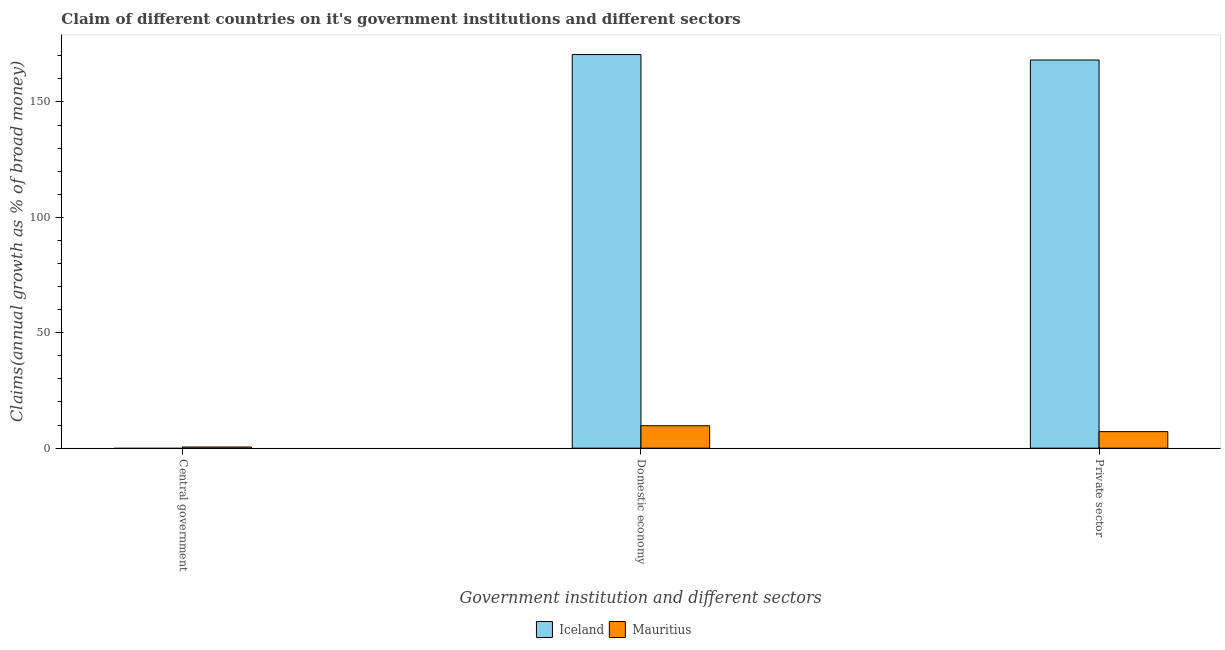How many different coloured bars are there?
Offer a terse response. 2. Are the number of bars per tick equal to the number of legend labels?
Ensure brevity in your answer.  No. Are the number of bars on each tick of the X-axis equal?
Your response must be concise. No. How many bars are there on the 3rd tick from the left?
Offer a terse response. 2. What is the label of the 2nd group of bars from the left?
Your response must be concise. Domestic economy. What is the percentage of claim on the domestic economy in Mauritius?
Provide a succinct answer. 9.7. Across all countries, what is the maximum percentage of claim on the central government?
Offer a very short reply. 0.49. Across all countries, what is the minimum percentage of claim on the central government?
Offer a terse response. 0. In which country was the percentage of claim on the private sector maximum?
Provide a succinct answer. Iceland. What is the total percentage of claim on the private sector in the graph?
Your answer should be compact. 175.32. What is the difference between the percentage of claim on the private sector in Iceland and that in Mauritius?
Offer a very short reply. 161. What is the difference between the percentage of claim on the private sector in Iceland and the percentage of claim on the central government in Mauritius?
Keep it short and to the point. 167.67. What is the average percentage of claim on the private sector per country?
Your answer should be very brief. 87.66. What is the difference between the percentage of claim on the private sector and percentage of claim on the domestic economy in Mauritius?
Offer a terse response. -2.55. What is the ratio of the percentage of claim on the domestic economy in Mauritius to that in Iceland?
Offer a very short reply. 0.06. What is the difference between the highest and the second highest percentage of claim on the domestic economy?
Offer a terse response. 160.81. What is the difference between the highest and the lowest percentage of claim on the private sector?
Make the answer very short. 161. In how many countries, is the percentage of claim on the central government greater than the average percentage of claim on the central government taken over all countries?
Provide a short and direct response. 1. Is the sum of the percentage of claim on the private sector in Mauritius and Iceland greater than the maximum percentage of claim on the domestic economy across all countries?
Ensure brevity in your answer.  Yes. Is it the case that in every country, the sum of the percentage of claim on the central government and percentage of claim on the domestic economy is greater than the percentage of claim on the private sector?
Ensure brevity in your answer.  Yes. Does the graph contain any zero values?
Provide a short and direct response. Yes. Does the graph contain grids?
Your answer should be very brief. No. Where does the legend appear in the graph?
Provide a succinct answer. Bottom center. How many legend labels are there?
Your answer should be very brief. 2. How are the legend labels stacked?
Offer a terse response. Horizontal. What is the title of the graph?
Your response must be concise. Claim of different countries on it's government institutions and different sectors. What is the label or title of the X-axis?
Keep it short and to the point. Government institution and different sectors. What is the label or title of the Y-axis?
Ensure brevity in your answer.  Claims(annual growth as % of broad money). What is the Claims(annual growth as % of broad money) of Mauritius in Central government?
Your answer should be compact. 0.49. What is the Claims(annual growth as % of broad money) in Iceland in Domestic economy?
Offer a terse response. 170.52. What is the Claims(annual growth as % of broad money) of Mauritius in Domestic economy?
Your answer should be compact. 9.7. What is the Claims(annual growth as % of broad money) of Iceland in Private sector?
Make the answer very short. 168.16. What is the Claims(annual growth as % of broad money) of Mauritius in Private sector?
Give a very brief answer. 7.16. Across all Government institution and different sectors, what is the maximum Claims(annual growth as % of broad money) in Iceland?
Provide a short and direct response. 170.52. Across all Government institution and different sectors, what is the maximum Claims(annual growth as % of broad money) of Mauritius?
Your answer should be very brief. 9.7. Across all Government institution and different sectors, what is the minimum Claims(annual growth as % of broad money) in Iceland?
Provide a short and direct response. 0. Across all Government institution and different sectors, what is the minimum Claims(annual growth as % of broad money) in Mauritius?
Provide a succinct answer. 0.49. What is the total Claims(annual growth as % of broad money) of Iceland in the graph?
Provide a short and direct response. 338.68. What is the total Claims(annual growth as % of broad money) in Mauritius in the graph?
Your response must be concise. 17.35. What is the difference between the Claims(annual growth as % of broad money) of Mauritius in Central government and that in Domestic economy?
Provide a short and direct response. -9.21. What is the difference between the Claims(annual growth as % of broad money) of Mauritius in Central government and that in Private sector?
Provide a succinct answer. -6.67. What is the difference between the Claims(annual growth as % of broad money) of Iceland in Domestic economy and that in Private sector?
Your answer should be very brief. 2.36. What is the difference between the Claims(annual growth as % of broad money) in Mauritius in Domestic economy and that in Private sector?
Make the answer very short. 2.55. What is the difference between the Claims(annual growth as % of broad money) in Iceland in Domestic economy and the Claims(annual growth as % of broad money) in Mauritius in Private sector?
Give a very brief answer. 163.36. What is the average Claims(annual growth as % of broad money) in Iceland per Government institution and different sectors?
Keep it short and to the point. 112.89. What is the average Claims(annual growth as % of broad money) in Mauritius per Government institution and different sectors?
Offer a terse response. 5.78. What is the difference between the Claims(annual growth as % of broad money) in Iceland and Claims(annual growth as % of broad money) in Mauritius in Domestic economy?
Ensure brevity in your answer.  160.81. What is the difference between the Claims(annual growth as % of broad money) in Iceland and Claims(annual growth as % of broad money) in Mauritius in Private sector?
Give a very brief answer. 161. What is the ratio of the Claims(annual growth as % of broad money) of Mauritius in Central government to that in Domestic economy?
Provide a short and direct response. 0.05. What is the ratio of the Claims(annual growth as % of broad money) of Mauritius in Central government to that in Private sector?
Your answer should be very brief. 0.07. What is the ratio of the Claims(annual growth as % of broad money) of Iceland in Domestic economy to that in Private sector?
Provide a short and direct response. 1.01. What is the ratio of the Claims(annual growth as % of broad money) of Mauritius in Domestic economy to that in Private sector?
Provide a short and direct response. 1.36. What is the difference between the highest and the second highest Claims(annual growth as % of broad money) of Mauritius?
Provide a short and direct response. 2.55. What is the difference between the highest and the lowest Claims(annual growth as % of broad money) in Iceland?
Give a very brief answer. 170.52. What is the difference between the highest and the lowest Claims(annual growth as % of broad money) in Mauritius?
Offer a terse response. 9.21. 